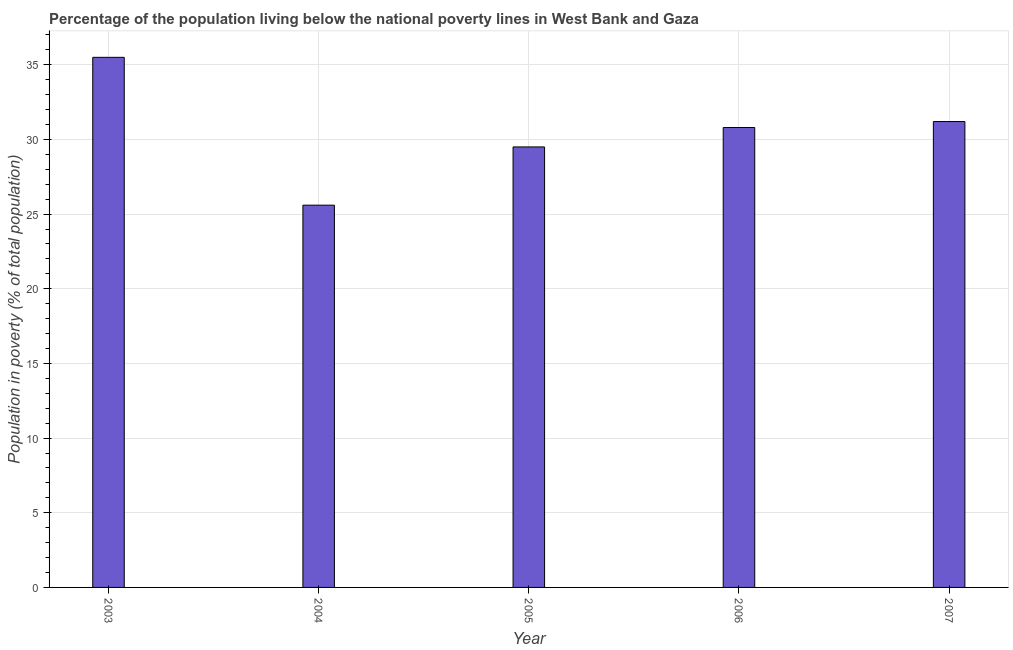Does the graph contain grids?
Your response must be concise. Yes. What is the title of the graph?
Make the answer very short. Percentage of the population living below the national poverty lines in West Bank and Gaza. What is the label or title of the Y-axis?
Make the answer very short. Population in poverty (% of total population). What is the percentage of population living below poverty line in 2003?
Offer a terse response. 35.5. Across all years, what is the maximum percentage of population living below poverty line?
Keep it short and to the point. 35.5. Across all years, what is the minimum percentage of population living below poverty line?
Provide a short and direct response. 25.6. What is the sum of the percentage of population living below poverty line?
Offer a terse response. 152.6. What is the average percentage of population living below poverty line per year?
Provide a short and direct response. 30.52. What is the median percentage of population living below poverty line?
Provide a succinct answer. 30.8. Do a majority of the years between 2003 and 2004 (inclusive) have percentage of population living below poverty line greater than 16 %?
Your answer should be compact. Yes. What is the ratio of the percentage of population living below poverty line in 2004 to that in 2005?
Provide a short and direct response. 0.87. Is the difference between the percentage of population living below poverty line in 2005 and 2007 greater than the difference between any two years?
Your answer should be compact. No. Is the sum of the percentage of population living below poverty line in 2003 and 2005 greater than the maximum percentage of population living below poverty line across all years?
Provide a short and direct response. Yes. What is the difference between the highest and the lowest percentage of population living below poverty line?
Keep it short and to the point. 9.9. Are the values on the major ticks of Y-axis written in scientific E-notation?
Offer a very short reply. No. What is the Population in poverty (% of total population) of 2003?
Ensure brevity in your answer.  35.5. What is the Population in poverty (% of total population) in 2004?
Offer a terse response. 25.6. What is the Population in poverty (% of total population) of 2005?
Provide a succinct answer. 29.5. What is the Population in poverty (% of total population) in 2006?
Offer a very short reply. 30.8. What is the Population in poverty (% of total population) in 2007?
Keep it short and to the point. 31.2. What is the difference between the Population in poverty (% of total population) in 2003 and 2004?
Make the answer very short. 9.9. What is the difference between the Population in poverty (% of total population) in 2003 and 2005?
Offer a terse response. 6. What is the difference between the Population in poverty (% of total population) in 2004 and 2005?
Give a very brief answer. -3.9. What is the difference between the Population in poverty (% of total population) in 2004 and 2007?
Ensure brevity in your answer.  -5.6. What is the difference between the Population in poverty (% of total population) in 2005 and 2007?
Give a very brief answer. -1.7. What is the ratio of the Population in poverty (% of total population) in 2003 to that in 2004?
Provide a succinct answer. 1.39. What is the ratio of the Population in poverty (% of total population) in 2003 to that in 2005?
Offer a very short reply. 1.2. What is the ratio of the Population in poverty (% of total population) in 2003 to that in 2006?
Give a very brief answer. 1.15. What is the ratio of the Population in poverty (% of total population) in 2003 to that in 2007?
Your response must be concise. 1.14. What is the ratio of the Population in poverty (% of total population) in 2004 to that in 2005?
Your response must be concise. 0.87. What is the ratio of the Population in poverty (% of total population) in 2004 to that in 2006?
Offer a very short reply. 0.83. What is the ratio of the Population in poverty (% of total population) in 2004 to that in 2007?
Provide a succinct answer. 0.82. What is the ratio of the Population in poverty (% of total population) in 2005 to that in 2006?
Keep it short and to the point. 0.96. What is the ratio of the Population in poverty (% of total population) in 2005 to that in 2007?
Offer a terse response. 0.95. What is the ratio of the Population in poverty (% of total population) in 2006 to that in 2007?
Provide a succinct answer. 0.99. 